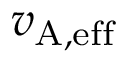Convert formula to latex. <formula><loc_0><loc_0><loc_500><loc_500>{ v } _ { A , e f f }</formula> 